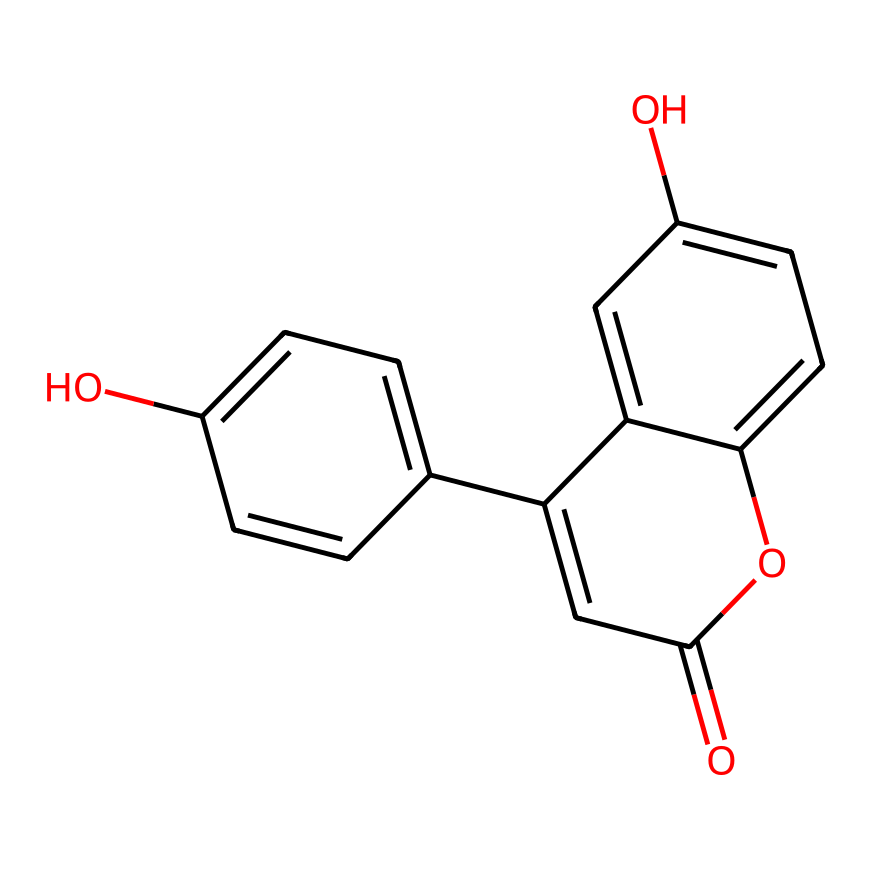what is the chemical name of this compound? The SMILES representation corresponds to a specific chemical structure, which can be identified by analyzing the rings and functional groups present. This specific structure corresponds to a type of fluorescent dye known as "Fluorescein."
Answer: Fluorescein how many rings are present in the structure? By examining the chemical structure depicted by the SMILES, we can count the number of distinct cyclic arrangements. In this case, there are three fused rings in the structure.
Answer: three what functional groups are present in this fluorescent dye? The SMILES structure indicates the presence of multiple hydroxyl (-OH) groups and a carbonyl (C=O) group. These functional groups are typically involved in the dye's properties.
Answer: hydroxyl and carbonyl what is the total number of carbon atoms in the structure? Looking at the SMILES representation, we can count the distinct carbon atoms within the structure. Upon analysis, there are 15 carbon atoms represented in the structure.
Answer: 15 how does the presence of the hydroxyl groups influence fluorescence? Hydroxyl groups can enhance the solubility of fluorescent dyes in aqueous solutions and can also impact the dye's ability to absorb and emit light, contributing to enhanced fluorescence.
Answer: enhances solubility what type of interactions would these fluorescent dyes have in a dance floor setting? In a dance floor setting, these dyes would interact primarily through photonic interactions, where they absorb light at specific wavelengths and then re-emit it, creating dynamic visual effects.
Answer: photonic interactions 